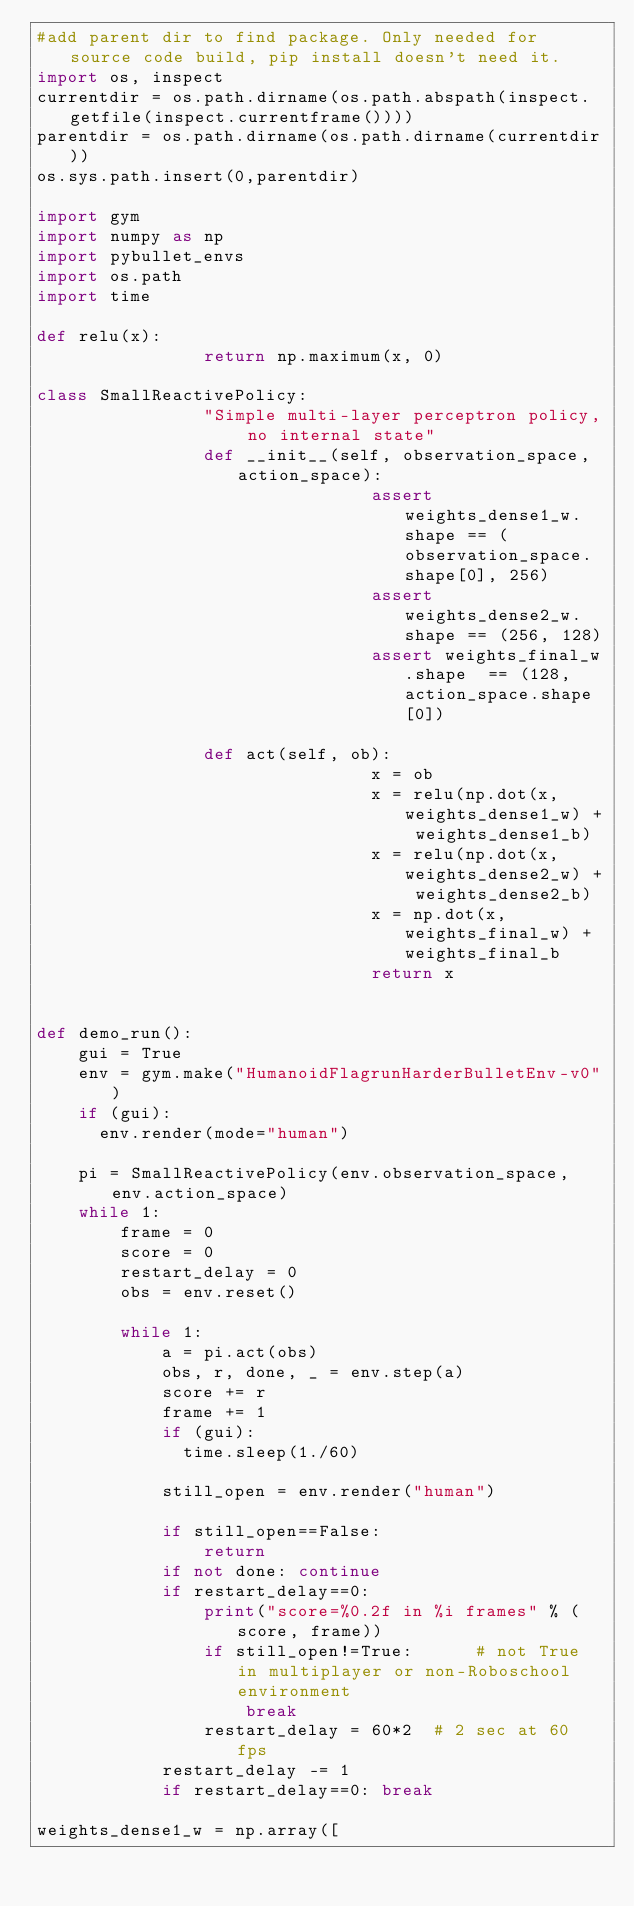<code> <loc_0><loc_0><loc_500><loc_500><_Python_>#add parent dir to find package. Only needed for source code build, pip install doesn't need it.
import os, inspect
currentdir = os.path.dirname(os.path.abspath(inspect.getfile(inspect.currentframe())))
parentdir = os.path.dirname(os.path.dirname(currentdir))
os.sys.path.insert(0,parentdir)

import gym
import numpy as np
import pybullet_envs
import os.path
import time

def relu(x):
                return np.maximum(x, 0)

class SmallReactivePolicy:
                "Simple multi-layer perceptron policy, no internal state"
                def __init__(self, observation_space, action_space):
                                assert weights_dense1_w.shape == (observation_space.shape[0], 256)
                                assert weights_dense2_w.shape == (256, 128)
                                assert weights_final_w.shape  == (128, action_space.shape[0])

                def act(self, ob):
                                x = ob
                                x = relu(np.dot(x, weights_dense1_w) + weights_dense1_b)
                                x = relu(np.dot(x, weights_dense2_w) + weights_dense2_b)
                                x = np.dot(x, weights_final_w) + weights_final_b
                                return x


def demo_run():
    gui = True
    env = gym.make("HumanoidFlagrunHarderBulletEnv-v0")
    if (gui):
      env.render(mode="human")

    pi = SmallReactivePolicy(env.observation_space, env.action_space)
    while 1:
        frame = 0
        score = 0
        restart_delay = 0
        obs = env.reset()

        while 1:
            a = pi.act(obs)
            obs, r, done, _ = env.step(a)
            score += r
            frame += 1
            if (gui):
              time.sleep(1./60)

            still_open = env.render("human")

            if still_open==False:
                return
            if not done: continue
            if restart_delay==0:
                print("score=%0.2f in %i frames" % (score, frame))
                if still_open!=True:      # not True in multiplayer or non-Roboschool environment
                    break
                restart_delay = 60*2  # 2 sec at 60 fps
            restart_delay -= 1
            if restart_delay==0: break

weights_dense1_w = np.array([</code> 